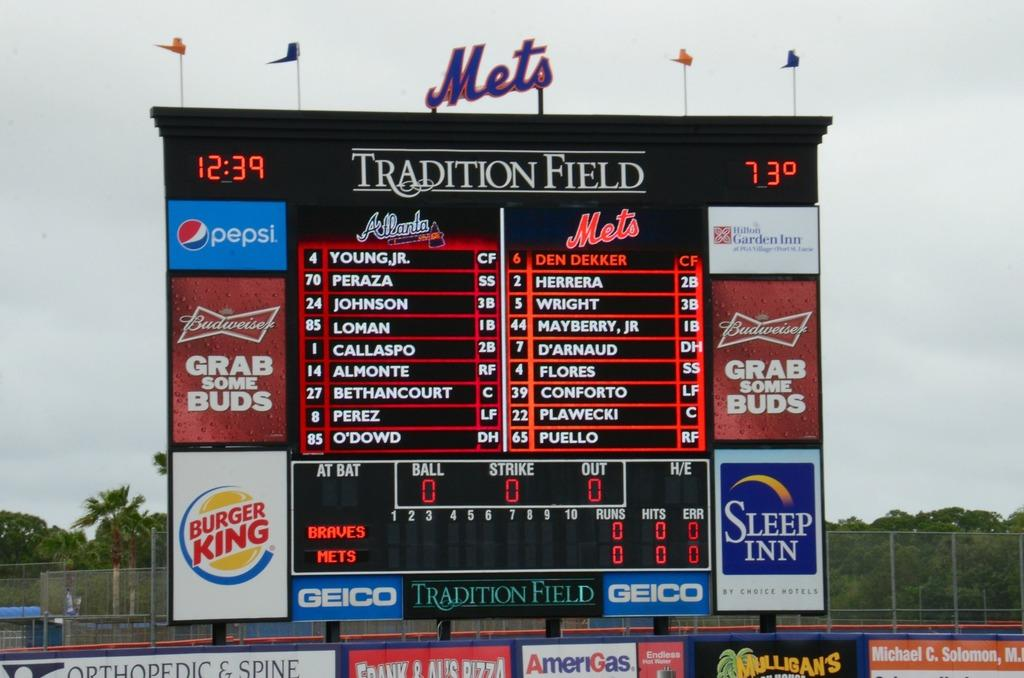<image>
Provide a brief description of the given image. The lineup for Atlanta and the Mets for a baseball game. 